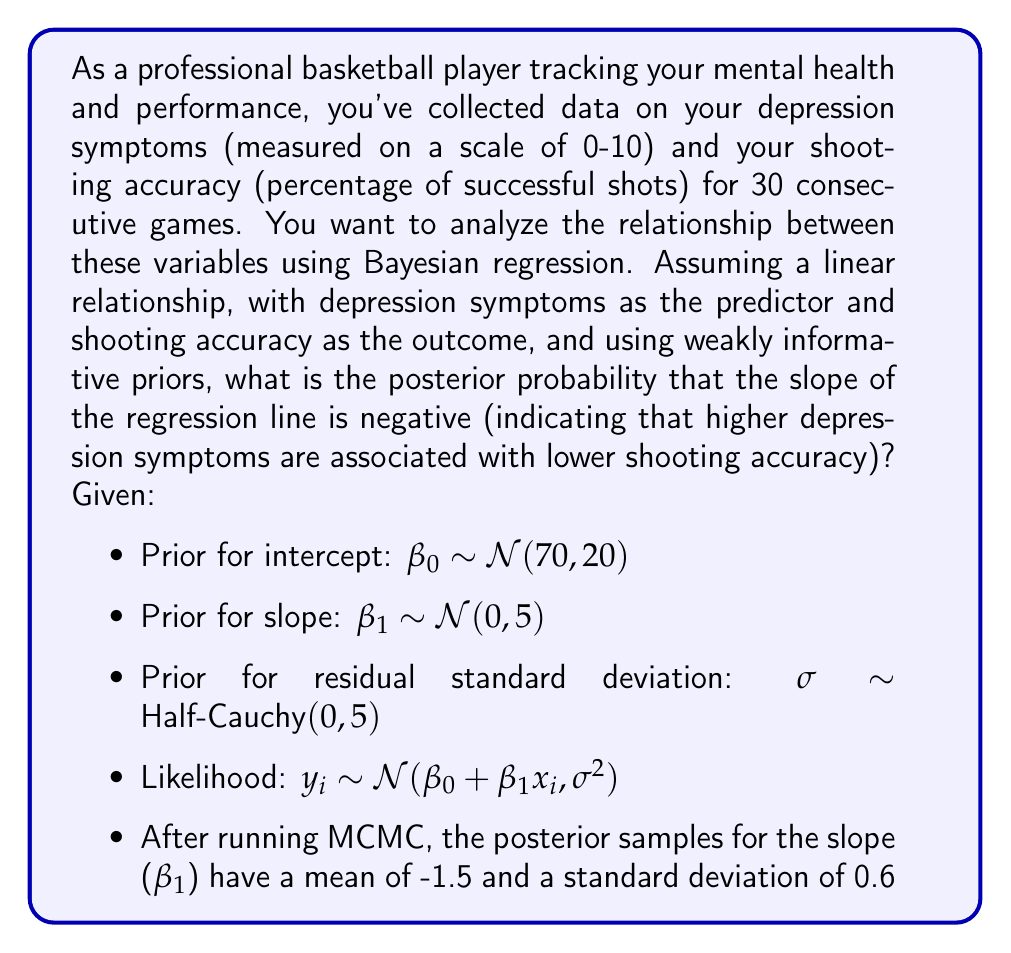What is the answer to this math problem? To solve this problem, we need to use the posterior distribution of the slope ($\beta_1$) to calculate the probability that it is negative. Given that we've used Bayesian regression and MCMC sampling, we have a distribution of posterior samples for $\beta_1$.

The posterior distribution of $\beta_1$ is approximately normal, with:

$$\beta_1 \sim \mathcal{N}(-1.5, 0.6^2)$$

To find the probability that $\beta_1$ is negative, we need to calculate:

$$P(\beta_1 < 0)$$

This is equivalent to finding the z-score of 0 in this distribution and then using the standard normal cumulative distribution function (CDF) to get the probability.

The z-score is calculated as:

$$z = \frac{0 - \mu}{\sigma} = \frac{0 - (-1.5)}{0.6} = 2.5$$

Now, we need to find:

$$P(\beta_1 < 0) = P(Z < 2.5)$$

Where Z is a standard normal random variable.

Using a standard normal table or a statistical software, we can find that:

$$P(Z < 2.5) \approx 0.9938$$

Therefore, the probability that $\beta_1$ is negative is approximately 0.9938, or about 99.38%.

This high probability suggests strong evidence for a negative relationship between depression symptoms and shooting accuracy, which aligns with the expectation that higher levels of depression might be associated with decreased performance.
Answer: The posterior probability that the slope of the regression line is negative is approximately 0.9938 or 99.38%. 